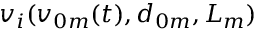<formula> <loc_0><loc_0><loc_500><loc_500>v _ { i } ( v _ { 0 m } ( t ) , d _ { 0 m } , L _ { m } )</formula> 